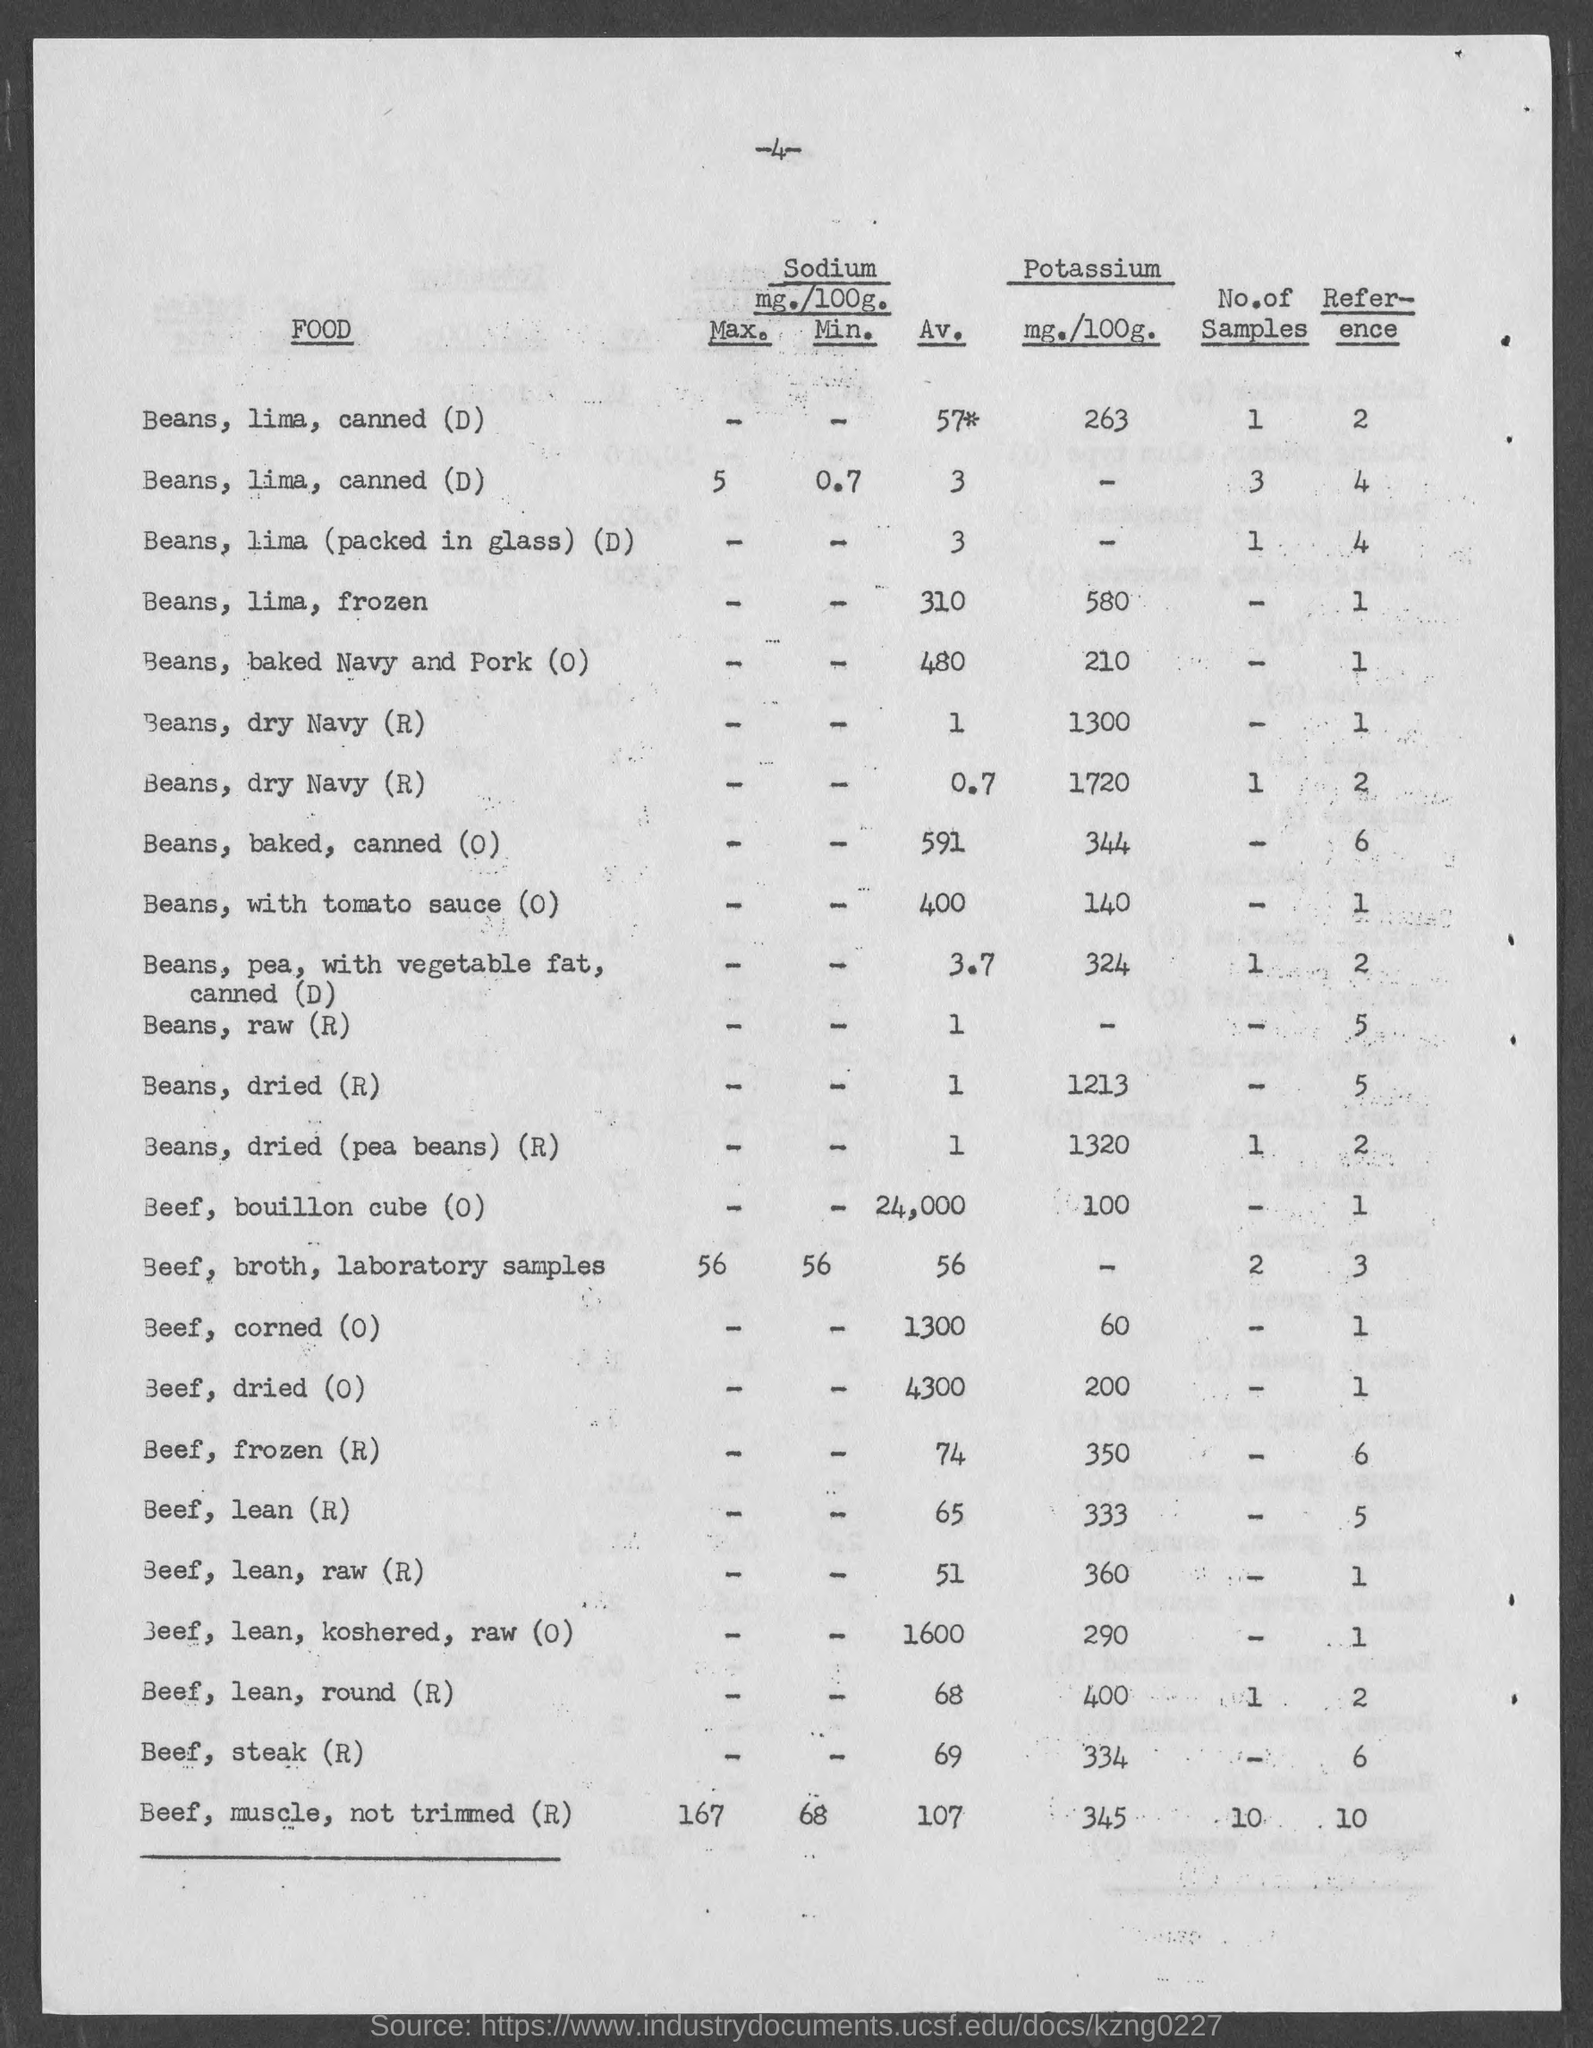What is the number at top of the page ?
Keep it short and to the point. 4. 